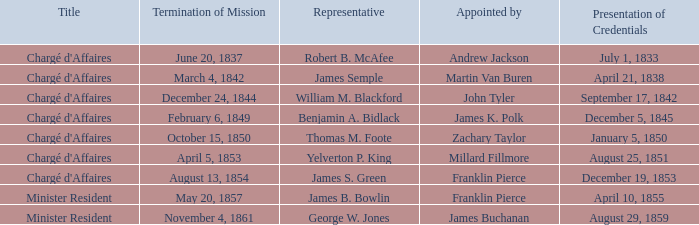What Title has a Termination of Mission of November 4, 1861? Minister Resident. 